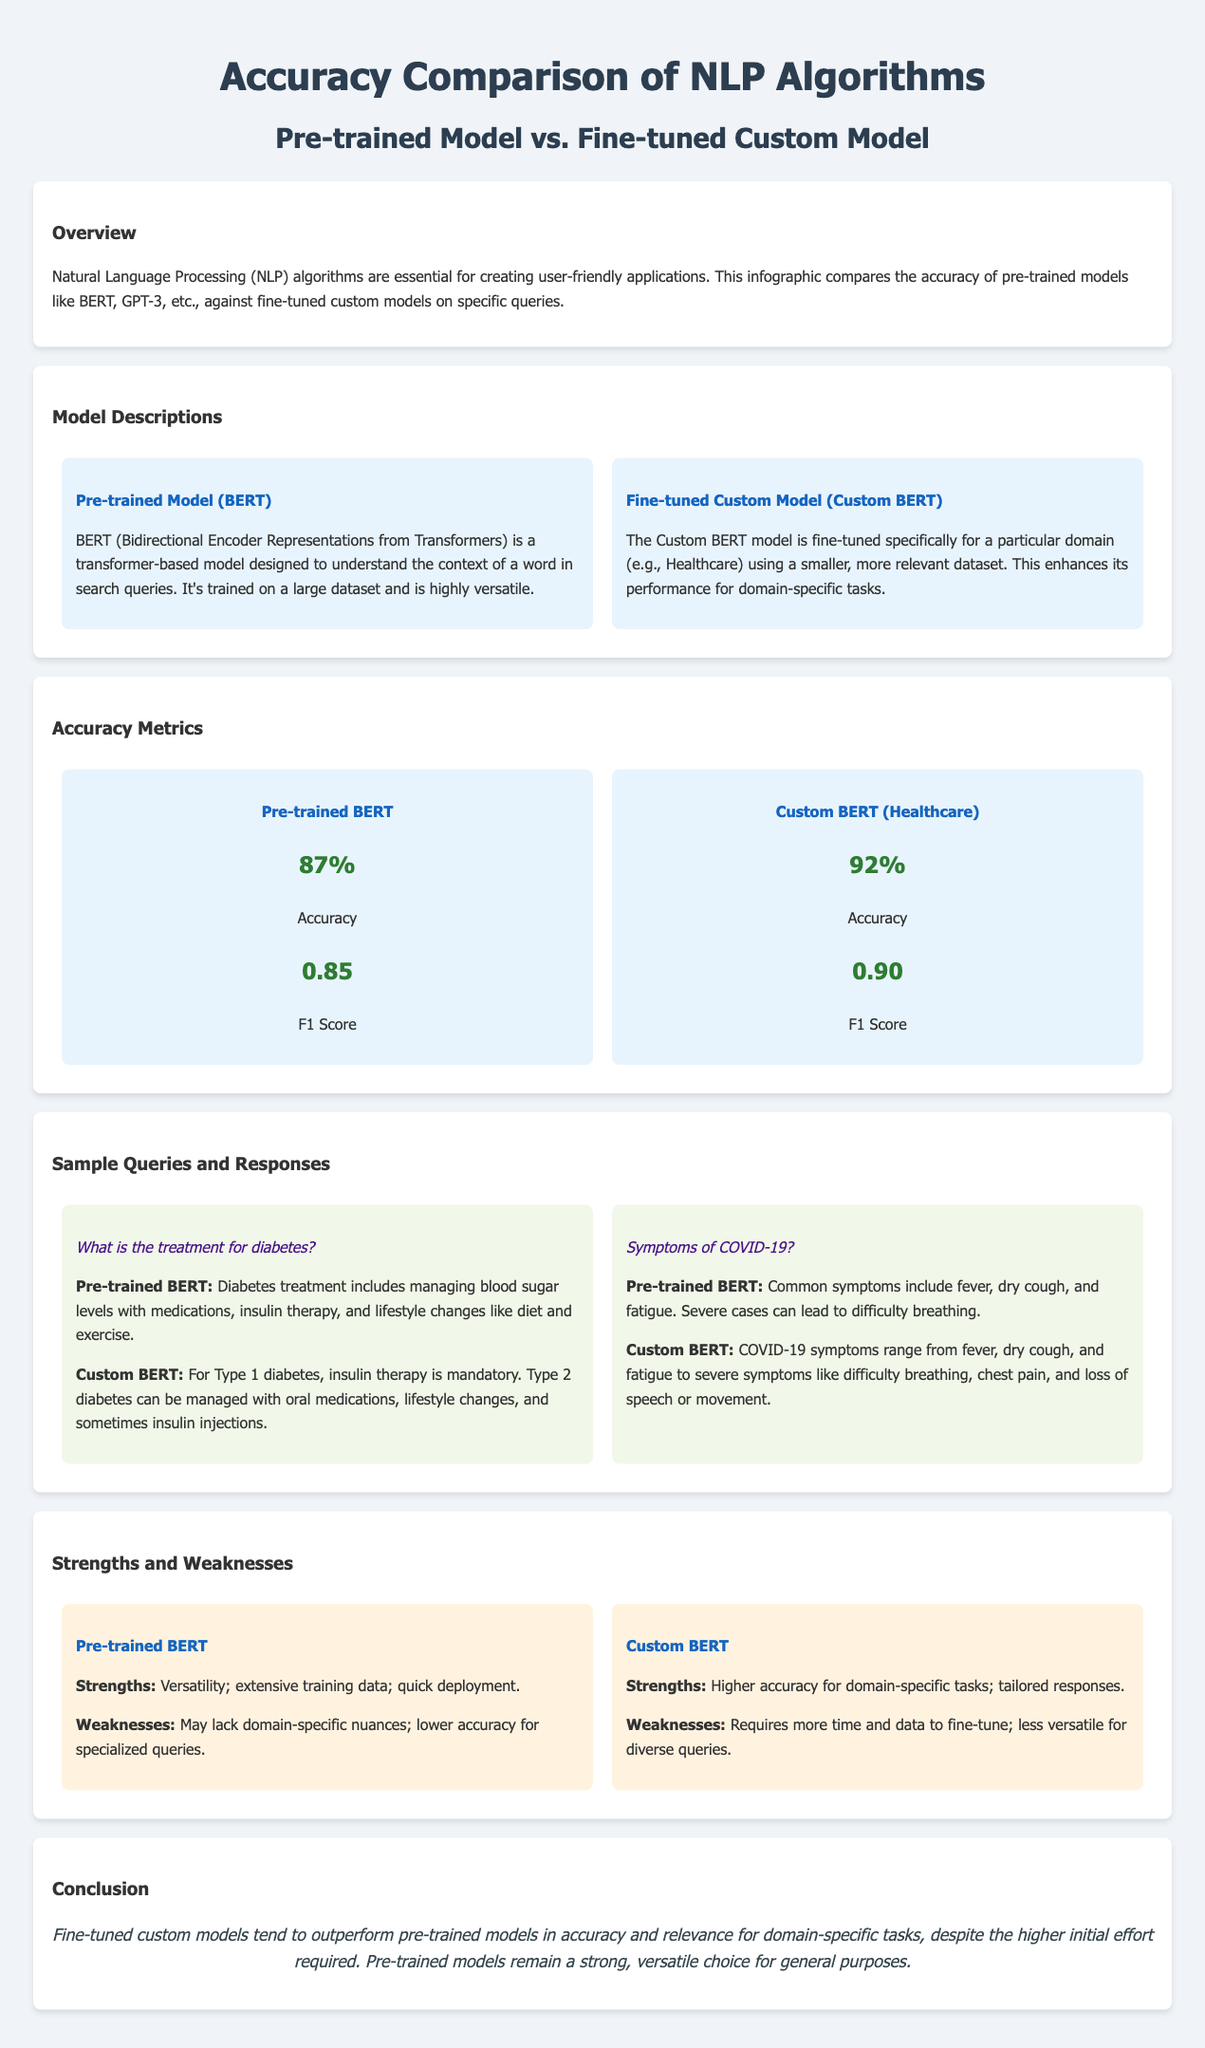What are the two models compared in the infographic? The infographic compares the Pre-trained Model (BERT) and Fine-tuned Custom Model (Custom BERT).
Answer: Pre-trained Model (BERT) and Fine-tuned Custom Model (Custom BERT) What is the accuracy of the Custom BERT model? The accuracy of the Custom BERT model is stated in the accuracy metrics section of the document as 92%.
Answer: 92% What is the F1 Score of the Pre-trained BERT model? The F1 Score of the Pre-trained BERT model is found in the accuracy metrics section, which lists it as 0.85.
Answer: 0.85 Which query did the Custom BERT model provide more detailed information on? The Custom BERT model provided more detailed information in response to the query "What is the treatment for diabetes?"
Answer: Treatment for diabetes What are a strength and a weakness of the Custom BERT model? The strengths and weaknesses are detailed in the strengths and weaknesses section; a strength is higher accuracy for domain-specific tasks and a weakness is requiring more time to fine-tune.
Answer: Higher accuracy for domain-specific tasks; requires more time What is the main conclusion drawn in the infographic? The infographic concludes that fine-tuned custom models tend to outperform pre-trained models in accuracy for domain-specific tasks.
Answer: Fine-tuned custom models outperform pre-trained models What is one example of a query listed in the sample queries? The sample queries section provides examples; one such query is "Symptoms of COVID-19?"
Answer: Symptoms of COVID-19? What characteristic makes Pre-trained BERT quick to deploy? The characteristics making Pre-trained BERT quick to deploy are mentioned as its versatility and extensive training data.
Answer: Versatility; extensive training data 